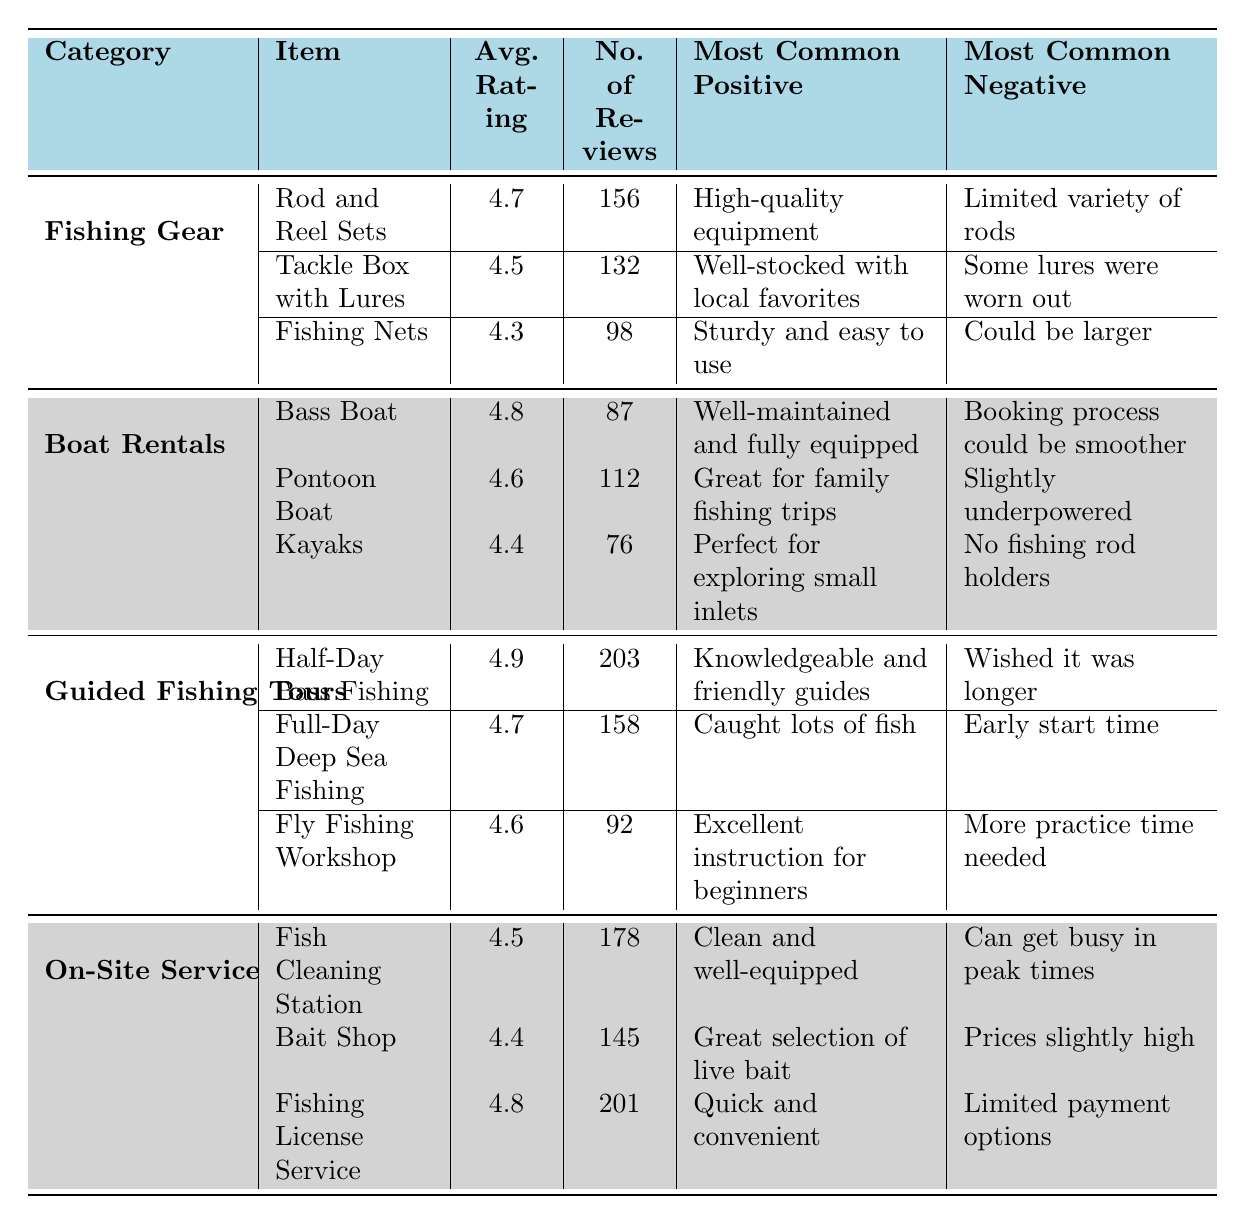What is the average rating of the "Tackle Box with Lures"? The table shows that the "Tackle Box with Lures" has an average rating of 4.5.
Answer: 4.5 Which item has the highest number of reviews in the "Guided Fishing Tours" category? The table indicates that the "Half-Day Bass Fishing" has the highest number of reviews with 203.
Answer: Half-Day Bass Fishing What is the most common negative comment regarding the "Bass Boat"? According to the table, the most common negative comment for the "Bass Boat" is "Booking process could be smoother."
Answer: Booking process could be smoother How many more reviews does the "Fishing License Service" have compared to the "Kayaks"? The "Fishing License Service" has 201 reviews and "Kayaks" has 76 reviews. The difference is 201 - 76 = 125.
Answer: 125 Is the average rating for "Fishing Nets" higher than the average rating for "Tackle Box with Lures"? The average rating for "Fishing Nets" is 4.3 and for "Tackle Box with Lures" it is 4.5. Thus, 4.3 is not higher than 4.5.
Answer: No Which category has the item with the highest average rating? The category "Guided Fishing Tours" has the item "Half-Day Bass Fishing" with the highest average rating of 4.9.
Answer: Guided Fishing Tours What is the average rating of all items in the "On-Site Services" category? The average ratings for the items are 4.5 (Fish Cleaning Station), 4.4 (Bait Shop), and 4.8 (Fishing License Service). Their average is (4.5 + 4.4 + 4.8) / 3 = 4.5667, approximately 4.57 when rounded to two decimal places.
Answer: 4.57 In which category is the item "Pontoon Boat" found? The table shows that the "Pontoon Boat" is listed under the "Boat Rentals" category.
Answer: Boat Rentals What item had the lowest average rating in the "Fishing Gear" category? The "Fishing Nets" had the lowest average rating in the "Fishing Gear" category with a rating of 4.3.
Answer: Fishing Nets What percentage of total reviews for the "Fishing Gear" category is represented by the reviews for "Rod and Reel Sets"? The total reviews for "Fishing Gear" are 156 (Rod and Reel Sets) + 132 (Tackle Box with Lures) + 98 (Fishing Nets) = 386. The percentage for "Rod and Reel Sets" is (156 / 386) * 100 = 40.4%, approximately 40.4%.
Answer: 40.4% 